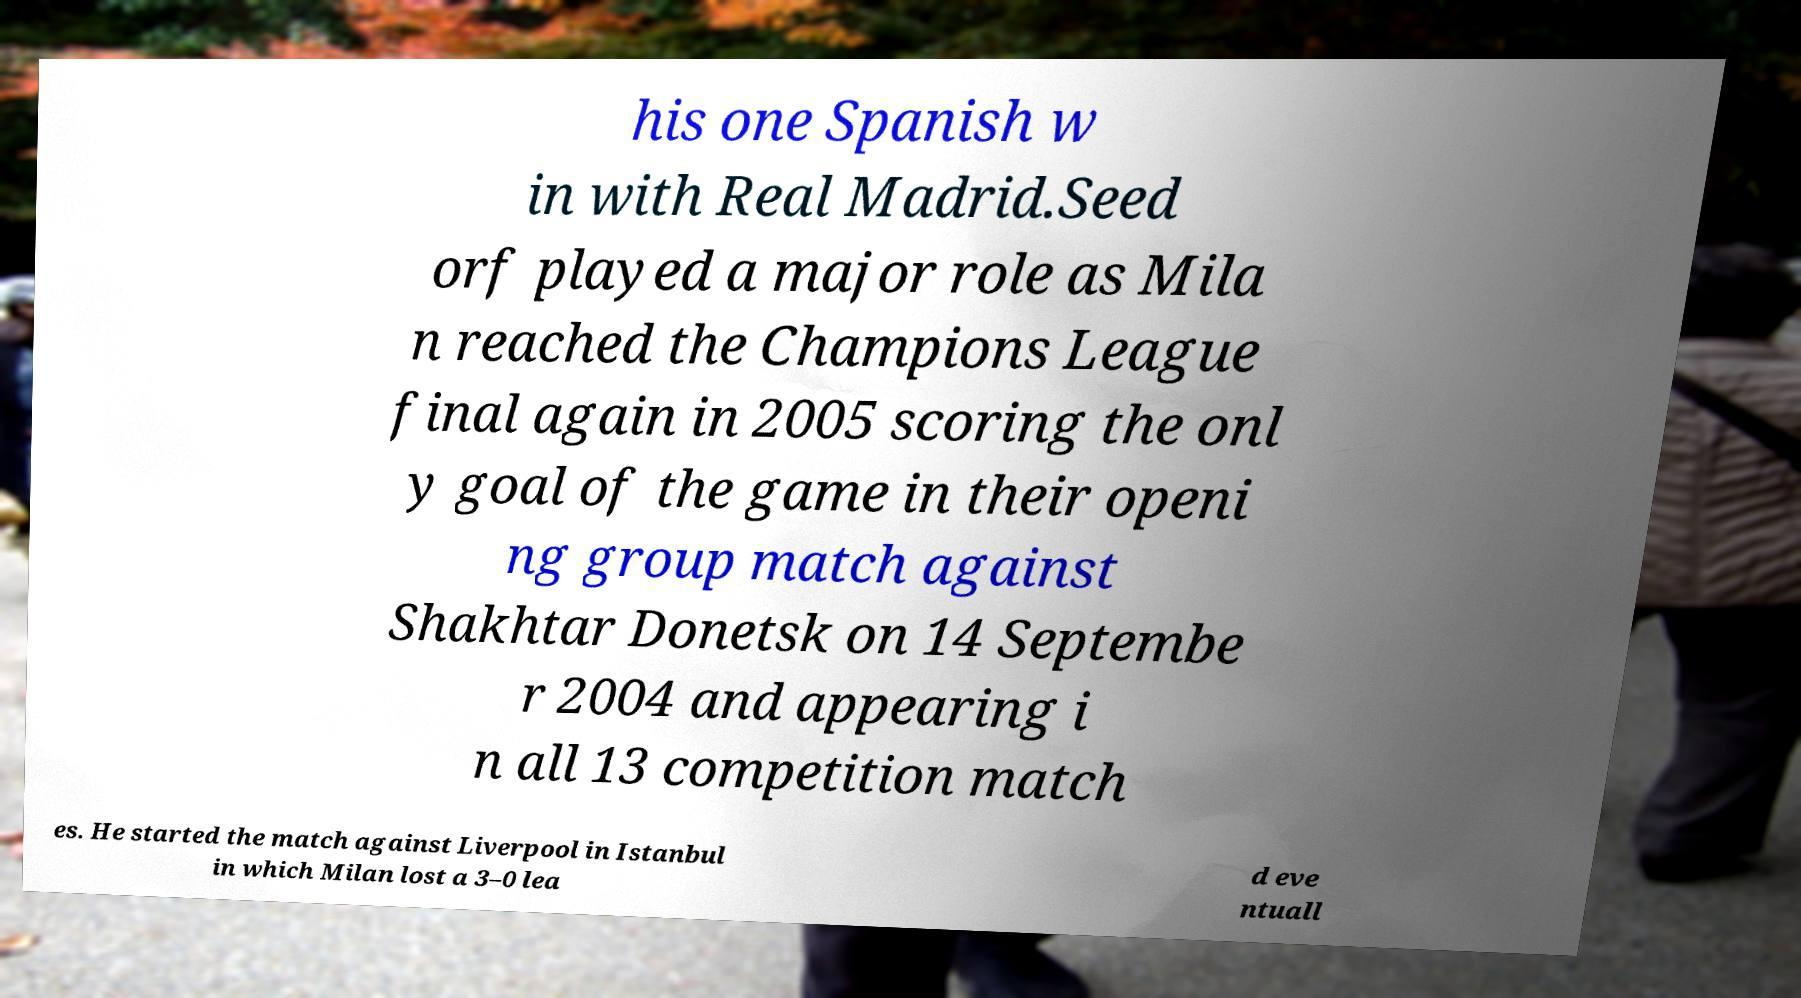Can you accurately transcribe the text from the provided image for me? his one Spanish w in with Real Madrid.Seed orf played a major role as Mila n reached the Champions League final again in 2005 scoring the onl y goal of the game in their openi ng group match against Shakhtar Donetsk on 14 Septembe r 2004 and appearing i n all 13 competition match es. He started the match against Liverpool in Istanbul in which Milan lost a 3–0 lea d eve ntuall 